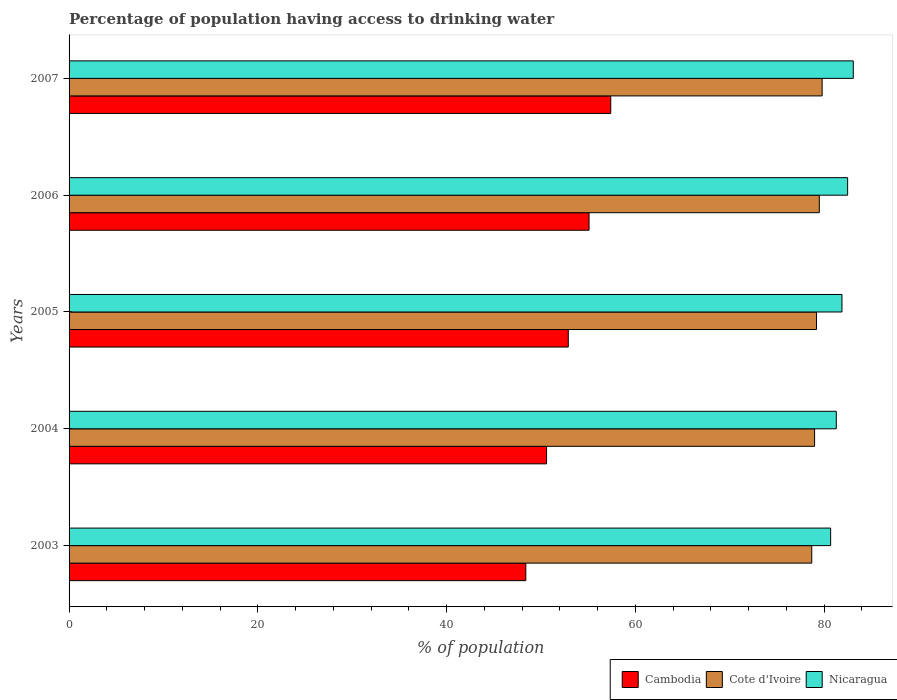How many different coloured bars are there?
Keep it short and to the point. 3. How many groups of bars are there?
Your response must be concise. 5. Are the number of bars on each tick of the Y-axis equal?
Ensure brevity in your answer.  Yes. How many bars are there on the 1st tick from the top?
Keep it short and to the point. 3. How many bars are there on the 4th tick from the bottom?
Offer a terse response. 3. What is the percentage of population having access to drinking water in Cote d'Ivoire in 2006?
Keep it short and to the point. 79.5. Across all years, what is the maximum percentage of population having access to drinking water in Cote d'Ivoire?
Ensure brevity in your answer.  79.8. Across all years, what is the minimum percentage of population having access to drinking water in Cambodia?
Give a very brief answer. 48.4. What is the total percentage of population having access to drinking water in Cote d'Ivoire in the graph?
Ensure brevity in your answer.  396.2. What is the difference between the percentage of population having access to drinking water in Cambodia in 2004 and that in 2005?
Offer a terse response. -2.3. What is the difference between the percentage of population having access to drinking water in Cambodia in 2006 and the percentage of population having access to drinking water in Nicaragua in 2007?
Your response must be concise. -28. What is the average percentage of population having access to drinking water in Cote d'Ivoire per year?
Provide a succinct answer. 79.24. In the year 2007, what is the difference between the percentage of population having access to drinking water in Cote d'Ivoire and percentage of population having access to drinking water in Nicaragua?
Ensure brevity in your answer.  -3.3. In how many years, is the percentage of population having access to drinking water in Nicaragua greater than 12 %?
Offer a very short reply. 5. What is the ratio of the percentage of population having access to drinking water in Cambodia in 2004 to that in 2006?
Provide a short and direct response. 0.92. Is the percentage of population having access to drinking water in Cambodia in 2003 less than that in 2005?
Provide a succinct answer. Yes. What is the difference between the highest and the second highest percentage of population having access to drinking water in Cambodia?
Your answer should be very brief. 2.3. In how many years, is the percentage of population having access to drinking water in Cambodia greater than the average percentage of population having access to drinking water in Cambodia taken over all years?
Your response must be concise. 3. What does the 1st bar from the top in 2007 represents?
Offer a terse response. Nicaragua. What does the 3rd bar from the bottom in 2004 represents?
Offer a very short reply. Nicaragua. How many bars are there?
Provide a succinct answer. 15. Are all the bars in the graph horizontal?
Provide a short and direct response. Yes. How many years are there in the graph?
Offer a very short reply. 5. Does the graph contain grids?
Your answer should be very brief. No. Where does the legend appear in the graph?
Your answer should be very brief. Bottom right. How are the legend labels stacked?
Ensure brevity in your answer.  Horizontal. What is the title of the graph?
Offer a terse response. Percentage of population having access to drinking water. What is the label or title of the X-axis?
Your answer should be compact. % of population. What is the % of population of Cambodia in 2003?
Provide a succinct answer. 48.4. What is the % of population of Cote d'Ivoire in 2003?
Offer a very short reply. 78.7. What is the % of population of Nicaragua in 2003?
Provide a short and direct response. 80.7. What is the % of population of Cambodia in 2004?
Your answer should be very brief. 50.6. What is the % of population in Cote d'Ivoire in 2004?
Your response must be concise. 79. What is the % of population of Nicaragua in 2004?
Your answer should be compact. 81.3. What is the % of population in Cambodia in 2005?
Keep it short and to the point. 52.9. What is the % of population of Cote d'Ivoire in 2005?
Give a very brief answer. 79.2. What is the % of population in Nicaragua in 2005?
Your answer should be very brief. 81.9. What is the % of population of Cambodia in 2006?
Offer a terse response. 55.1. What is the % of population of Cote d'Ivoire in 2006?
Make the answer very short. 79.5. What is the % of population in Nicaragua in 2006?
Offer a terse response. 82.5. What is the % of population in Cambodia in 2007?
Keep it short and to the point. 57.4. What is the % of population of Cote d'Ivoire in 2007?
Give a very brief answer. 79.8. What is the % of population in Nicaragua in 2007?
Make the answer very short. 83.1. Across all years, what is the maximum % of population of Cambodia?
Your answer should be very brief. 57.4. Across all years, what is the maximum % of population in Cote d'Ivoire?
Keep it short and to the point. 79.8. Across all years, what is the maximum % of population of Nicaragua?
Give a very brief answer. 83.1. Across all years, what is the minimum % of population in Cambodia?
Give a very brief answer. 48.4. Across all years, what is the minimum % of population of Cote d'Ivoire?
Your answer should be very brief. 78.7. Across all years, what is the minimum % of population in Nicaragua?
Your answer should be compact. 80.7. What is the total % of population of Cambodia in the graph?
Your answer should be very brief. 264.4. What is the total % of population in Cote d'Ivoire in the graph?
Give a very brief answer. 396.2. What is the total % of population in Nicaragua in the graph?
Make the answer very short. 409.5. What is the difference between the % of population in Cambodia in 2003 and that in 2006?
Provide a succinct answer. -6.7. What is the difference between the % of population of Nicaragua in 2003 and that in 2006?
Your answer should be very brief. -1.8. What is the difference between the % of population in Nicaragua in 2003 and that in 2007?
Offer a very short reply. -2.4. What is the difference between the % of population in Cambodia in 2004 and that in 2005?
Keep it short and to the point. -2.3. What is the difference between the % of population of Cote d'Ivoire in 2004 and that in 2005?
Your answer should be very brief. -0.2. What is the difference between the % of population in Cambodia in 2004 and that in 2006?
Provide a succinct answer. -4.5. What is the difference between the % of population of Cote d'Ivoire in 2004 and that in 2006?
Provide a short and direct response. -0.5. What is the difference between the % of population of Nicaragua in 2004 and that in 2006?
Your response must be concise. -1.2. What is the difference between the % of population in Cote d'Ivoire in 2004 and that in 2007?
Make the answer very short. -0.8. What is the difference between the % of population in Cambodia in 2005 and that in 2006?
Your answer should be very brief. -2.2. What is the difference between the % of population in Cote d'Ivoire in 2005 and that in 2006?
Keep it short and to the point. -0.3. What is the difference between the % of population of Nicaragua in 2005 and that in 2006?
Offer a terse response. -0.6. What is the difference between the % of population of Cote d'Ivoire in 2006 and that in 2007?
Provide a succinct answer. -0.3. What is the difference between the % of population in Cambodia in 2003 and the % of population in Cote d'Ivoire in 2004?
Keep it short and to the point. -30.6. What is the difference between the % of population of Cambodia in 2003 and the % of population of Nicaragua in 2004?
Your response must be concise. -32.9. What is the difference between the % of population in Cambodia in 2003 and the % of population in Cote d'Ivoire in 2005?
Provide a succinct answer. -30.8. What is the difference between the % of population of Cambodia in 2003 and the % of population of Nicaragua in 2005?
Offer a terse response. -33.5. What is the difference between the % of population of Cote d'Ivoire in 2003 and the % of population of Nicaragua in 2005?
Your answer should be compact. -3.2. What is the difference between the % of population in Cambodia in 2003 and the % of population in Cote d'Ivoire in 2006?
Keep it short and to the point. -31.1. What is the difference between the % of population of Cambodia in 2003 and the % of population of Nicaragua in 2006?
Your response must be concise. -34.1. What is the difference between the % of population of Cote d'Ivoire in 2003 and the % of population of Nicaragua in 2006?
Ensure brevity in your answer.  -3.8. What is the difference between the % of population in Cambodia in 2003 and the % of population in Cote d'Ivoire in 2007?
Offer a very short reply. -31.4. What is the difference between the % of population of Cambodia in 2003 and the % of population of Nicaragua in 2007?
Your answer should be compact. -34.7. What is the difference between the % of population of Cote d'Ivoire in 2003 and the % of population of Nicaragua in 2007?
Your answer should be compact. -4.4. What is the difference between the % of population in Cambodia in 2004 and the % of population in Cote d'Ivoire in 2005?
Ensure brevity in your answer.  -28.6. What is the difference between the % of population of Cambodia in 2004 and the % of population of Nicaragua in 2005?
Offer a terse response. -31.3. What is the difference between the % of population of Cote d'Ivoire in 2004 and the % of population of Nicaragua in 2005?
Your answer should be very brief. -2.9. What is the difference between the % of population of Cambodia in 2004 and the % of population of Cote d'Ivoire in 2006?
Your answer should be very brief. -28.9. What is the difference between the % of population of Cambodia in 2004 and the % of population of Nicaragua in 2006?
Make the answer very short. -31.9. What is the difference between the % of population of Cambodia in 2004 and the % of population of Cote d'Ivoire in 2007?
Offer a terse response. -29.2. What is the difference between the % of population of Cambodia in 2004 and the % of population of Nicaragua in 2007?
Your answer should be very brief. -32.5. What is the difference between the % of population of Cote d'Ivoire in 2004 and the % of population of Nicaragua in 2007?
Provide a succinct answer. -4.1. What is the difference between the % of population in Cambodia in 2005 and the % of population in Cote d'Ivoire in 2006?
Provide a succinct answer. -26.6. What is the difference between the % of population in Cambodia in 2005 and the % of population in Nicaragua in 2006?
Keep it short and to the point. -29.6. What is the difference between the % of population of Cambodia in 2005 and the % of population of Cote d'Ivoire in 2007?
Your answer should be compact. -26.9. What is the difference between the % of population in Cambodia in 2005 and the % of population in Nicaragua in 2007?
Your response must be concise. -30.2. What is the difference between the % of population in Cambodia in 2006 and the % of population in Cote d'Ivoire in 2007?
Your response must be concise. -24.7. What is the difference between the % of population in Cote d'Ivoire in 2006 and the % of population in Nicaragua in 2007?
Provide a short and direct response. -3.6. What is the average % of population of Cambodia per year?
Provide a short and direct response. 52.88. What is the average % of population of Cote d'Ivoire per year?
Your answer should be compact. 79.24. What is the average % of population in Nicaragua per year?
Ensure brevity in your answer.  81.9. In the year 2003, what is the difference between the % of population in Cambodia and % of population in Cote d'Ivoire?
Provide a short and direct response. -30.3. In the year 2003, what is the difference between the % of population in Cambodia and % of population in Nicaragua?
Your answer should be very brief. -32.3. In the year 2004, what is the difference between the % of population of Cambodia and % of population of Cote d'Ivoire?
Your answer should be compact. -28.4. In the year 2004, what is the difference between the % of population of Cambodia and % of population of Nicaragua?
Your response must be concise. -30.7. In the year 2005, what is the difference between the % of population in Cambodia and % of population in Cote d'Ivoire?
Provide a succinct answer. -26.3. In the year 2006, what is the difference between the % of population in Cambodia and % of population in Cote d'Ivoire?
Your answer should be very brief. -24.4. In the year 2006, what is the difference between the % of population of Cambodia and % of population of Nicaragua?
Your answer should be compact. -27.4. In the year 2007, what is the difference between the % of population in Cambodia and % of population in Cote d'Ivoire?
Keep it short and to the point. -22.4. In the year 2007, what is the difference between the % of population in Cambodia and % of population in Nicaragua?
Make the answer very short. -25.7. What is the ratio of the % of population of Cambodia in 2003 to that in 2004?
Your answer should be very brief. 0.96. What is the ratio of the % of population of Cambodia in 2003 to that in 2005?
Provide a succinct answer. 0.91. What is the ratio of the % of population of Nicaragua in 2003 to that in 2005?
Ensure brevity in your answer.  0.99. What is the ratio of the % of population of Cambodia in 2003 to that in 2006?
Ensure brevity in your answer.  0.88. What is the ratio of the % of population of Cote d'Ivoire in 2003 to that in 2006?
Keep it short and to the point. 0.99. What is the ratio of the % of population in Nicaragua in 2003 to that in 2006?
Offer a very short reply. 0.98. What is the ratio of the % of population in Cambodia in 2003 to that in 2007?
Provide a short and direct response. 0.84. What is the ratio of the % of population in Cote d'Ivoire in 2003 to that in 2007?
Your response must be concise. 0.99. What is the ratio of the % of population of Nicaragua in 2003 to that in 2007?
Offer a very short reply. 0.97. What is the ratio of the % of population in Cambodia in 2004 to that in 2005?
Offer a very short reply. 0.96. What is the ratio of the % of population in Cambodia in 2004 to that in 2006?
Your answer should be compact. 0.92. What is the ratio of the % of population of Nicaragua in 2004 to that in 2006?
Your answer should be compact. 0.99. What is the ratio of the % of population in Cambodia in 2004 to that in 2007?
Your response must be concise. 0.88. What is the ratio of the % of population in Nicaragua in 2004 to that in 2007?
Keep it short and to the point. 0.98. What is the ratio of the % of population of Cambodia in 2005 to that in 2006?
Provide a short and direct response. 0.96. What is the ratio of the % of population in Cote d'Ivoire in 2005 to that in 2006?
Give a very brief answer. 1. What is the ratio of the % of population in Cambodia in 2005 to that in 2007?
Provide a succinct answer. 0.92. What is the ratio of the % of population of Cote d'Ivoire in 2005 to that in 2007?
Ensure brevity in your answer.  0.99. What is the ratio of the % of population of Nicaragua in 2005 to that in 2007?
Your response must be concise. 0.99. What is the ratio of the % of population in Cambodia in 2006 to that in 2007?
Offer a very short reply. 0.96. What is the ratio of the % of population in Cote d'Ivoire in 2006 to that in 2007?
Your answer should be very brief. 1. What is the ratio of the % of population in Nicaragua in 2006 to that in 2007?
Make the answer very short. 0.99. What is the difference between the highest and the second highest % of population of Cote d'Ivoire?
Offer a terse response. 0.3. What is the difference between the highest and the lowest % of population in Cote d'Ivoire?
Your answer should be very brief. 1.1. 